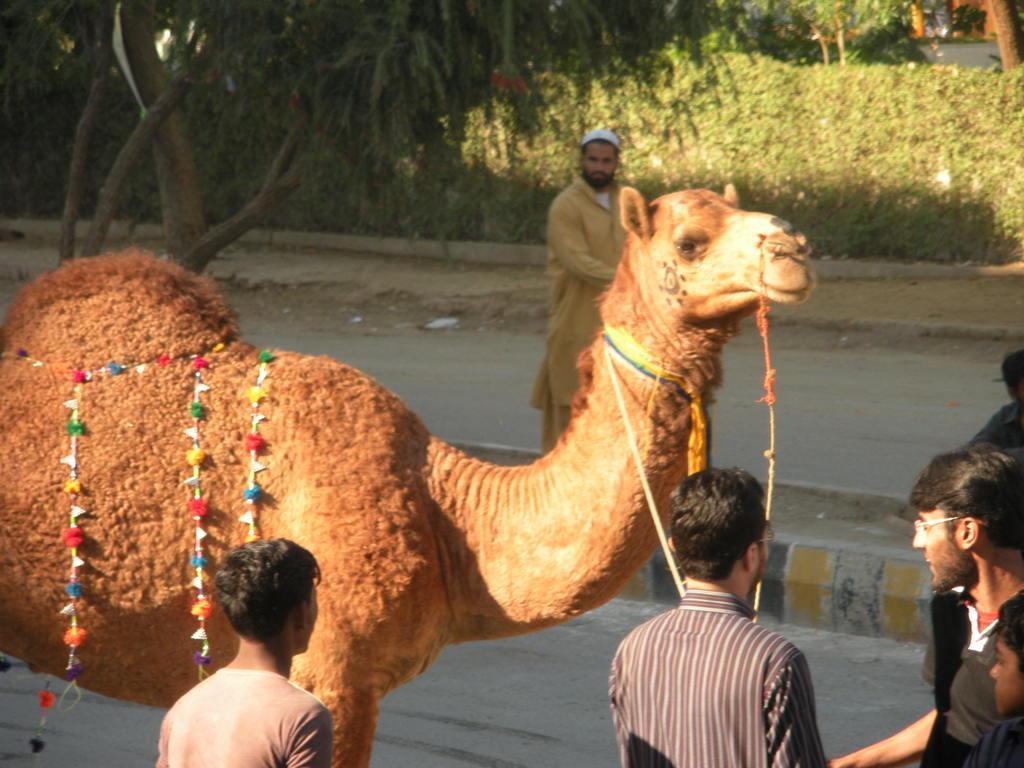How would you summarize this image in a sentence or two? In this image I can see the camel which is in brown color. To the side I can see the group of people with different color dresses. In the background I can see many trees. 